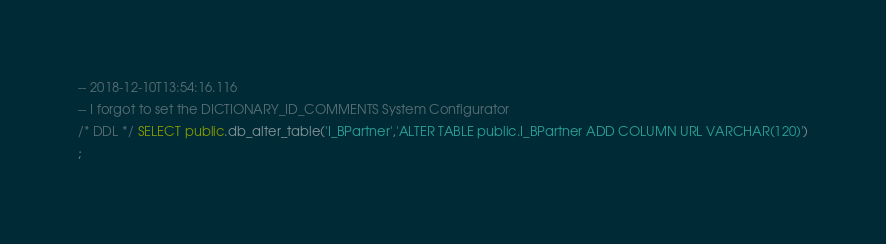Convert code to text. <code><loc_0><loc_0><loc_500><loc_500><_SQL_>-- 2018-12-10T13:54:16.116
-- I forgot to set the DICTIONARY_ID_COMMENTS System Configurator
/* DDL */ SELECT public.db_alter_table('I_BPartner','ALTER TABLE public.I_BPartner ADD COLUMN URL VARCHAR(120)')
;

</code> 